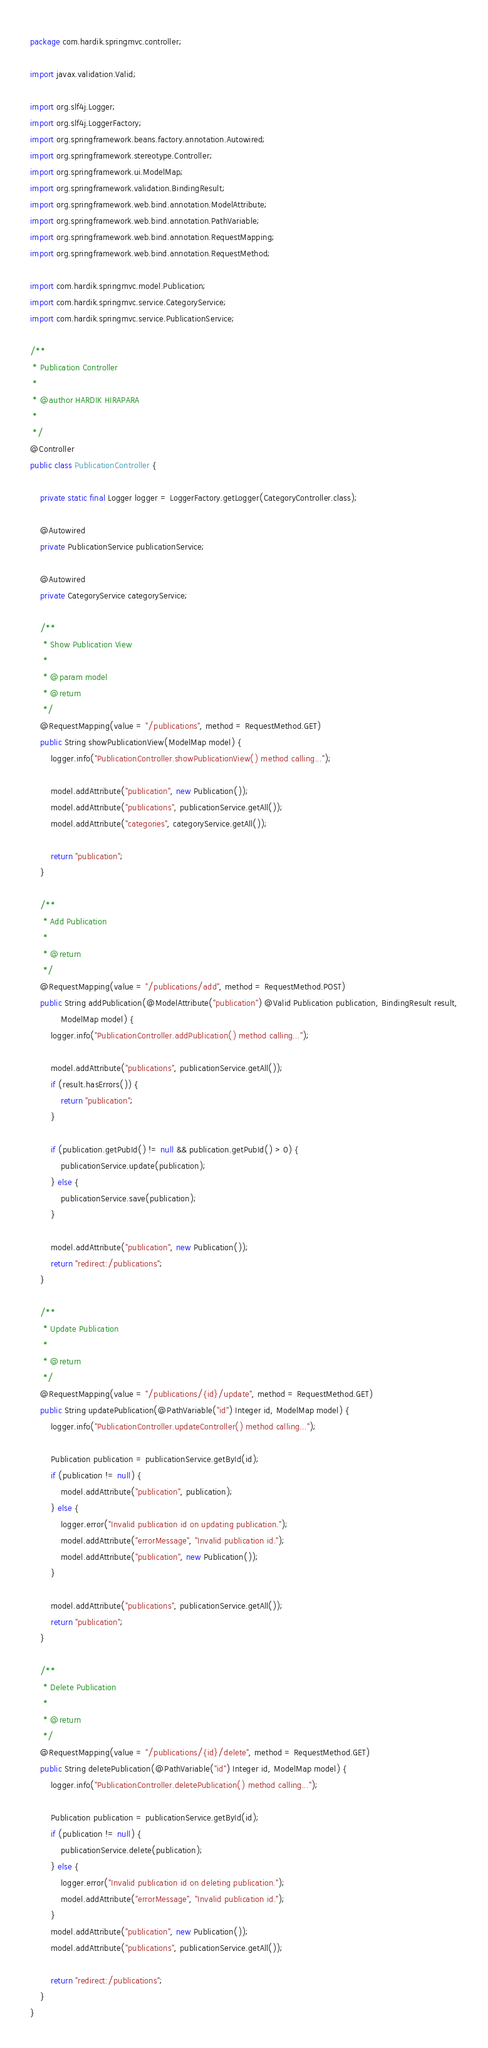<code> <loc_0><loc_0><loc_500><loc_500><_Java_>package com.hardik.springmvc.controller;

import javax.validation.Valid;

import org.slf4j.Logger;
import org.slf4j.LoggerFactory;
import org.springframework.beans.factory.annotation.Autowired;
import org.springframework.stereotype.Controller;
import org.springframework.ui.ModelMap;
import org.springframework.validation.BindingResult;
import org.springframework.web.bind.annotation.ModelAttribute;
import org.springframework.web.bind.annotation.PathVariable;
import org.springframework.web.bind.annotation.RequestMapping;
import org.springframework.web.bind.annotation.RequestMethod;

import com.hardik.springmvc.model.Publication;
import com.hardik.springmvc.service.CategoryService;
import com.hardik.springmvc.service.PublicationService;

/**
 * Publication Controller
 * 
 * @author HARDIK HIRAPARA
 *
 */
@Controller
public class PublicationController {

	private static final Logger logger = LoggerFactory.getLogger(CategoryController.class);

	@Autowired
	private PublicationService publicationService;

	@Autowired
	private CategoryService categoryService;

	/**
	 * Show Publication View
	 * 
	 * @param model
	 * @return
	 */
	@RequestMapping(value = "/publications", method = RequestMethod.GET)
	public String showPublicationView(ModelMap model) {
		logger.info("PublicationController.showPublicationView() method calling...");

		model.addAttribute("publication", new Publication());
		model.addAttribute("publications", publicationService.getAll());
		model.addAttribute("categories", categoryService.getAll());

		return "publication";
	}

	/**
	 * Add Publication
	 * 
	 * @return
	 */
	@RequestMapping(value = "/publications/add", method = RequestMethod.POST)
	public String addPublication(@ModelAttribute("publication") @Valid Publication publication, BindingResult result,
			ModelMap model) {
		logger.info("PublicationController.addPublication() method calling...");

		model.addAttribute("publications", publicationService.getAll());
		if (result.hasErrors()) {
			return "publication";
		}

		if (publication.getPubId() != null && publication.getPubId() > 0) {
			publicationService.update(publication);
		} else {
			publicationService.save(publication);
		}

		model.addAttribute("publication", new Publication());
		return "redirect:/publications";
	}

	/**
	 * Update Publication
	 * 
	 * @return
	 */
	@RequestMapping(value = "/publications/{id}/update", method = RequestMethod.GET)
	public String updatePublication(@PathVariable("id") Integer id, ModelMap model) {
		logger.info("PublicationController.updateController() method calling...");

		Publication publication = publicationService.getById(id);
		if (publication != null) {
			model.addAttribute("publication", publication);
		} else {
			logger.error("Invalid publication id on updating publication.");
			model.addAttribute("errorMessage", "Invalid publication id.");
			model.addAttribute("publication", new Publication());
		}

		model.addAttribute("publications", publicationService.getAll());
		return "publication";
	}

	/**
	 * Delete Publication
	 * 
	 * @return
	 */
	@RequestMapping(value = "/publications/{id}/delete", method = RequestMethod.GET)
	public String deletePublication(@PathVariable("id") Integer id, ModelMap model) {
		logger.info("PublicationController.deletePublication() method calling...");

		Publication publication = publicationService.getById(id);
		if (publication != null) {
			publicationService.delete(publication);
		} else {
			logger.error("Invalid publication id on deleting publication.");
			model.addAttribute("errorMessage", "Invalid publication id.");
		}
		model.addAttribute("publication", new Publication());
		model.addAttribute("publications", publicationService.getAll());

		return "redirect:/publications";
	}
}
</code> 